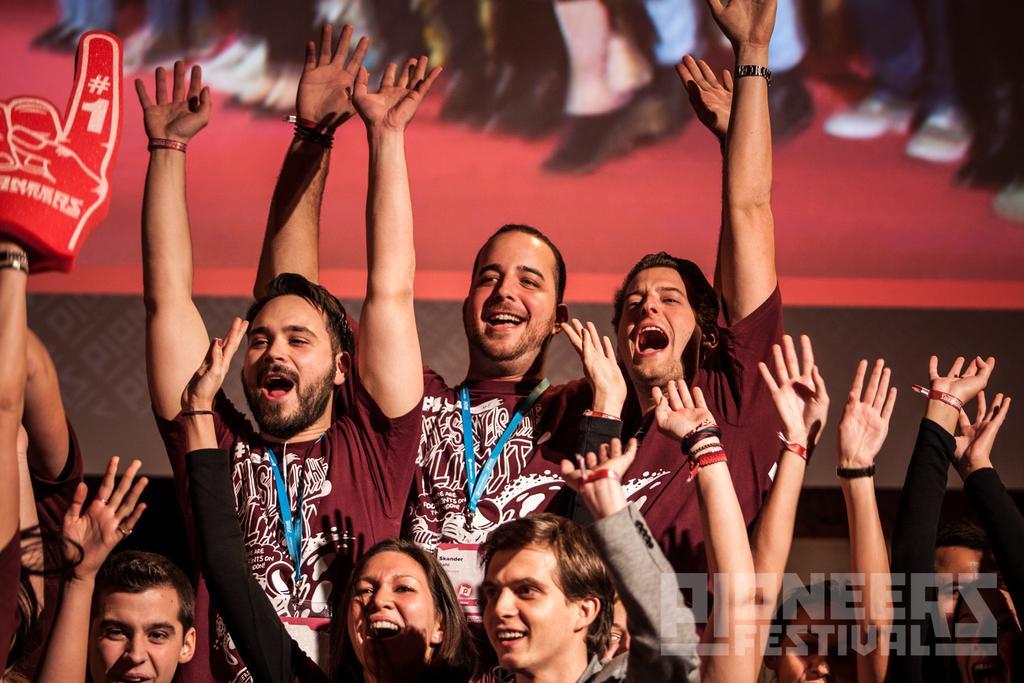Please provide a concise description of this image. In this image there are people standing and raised their hands up. There is a red color background. 